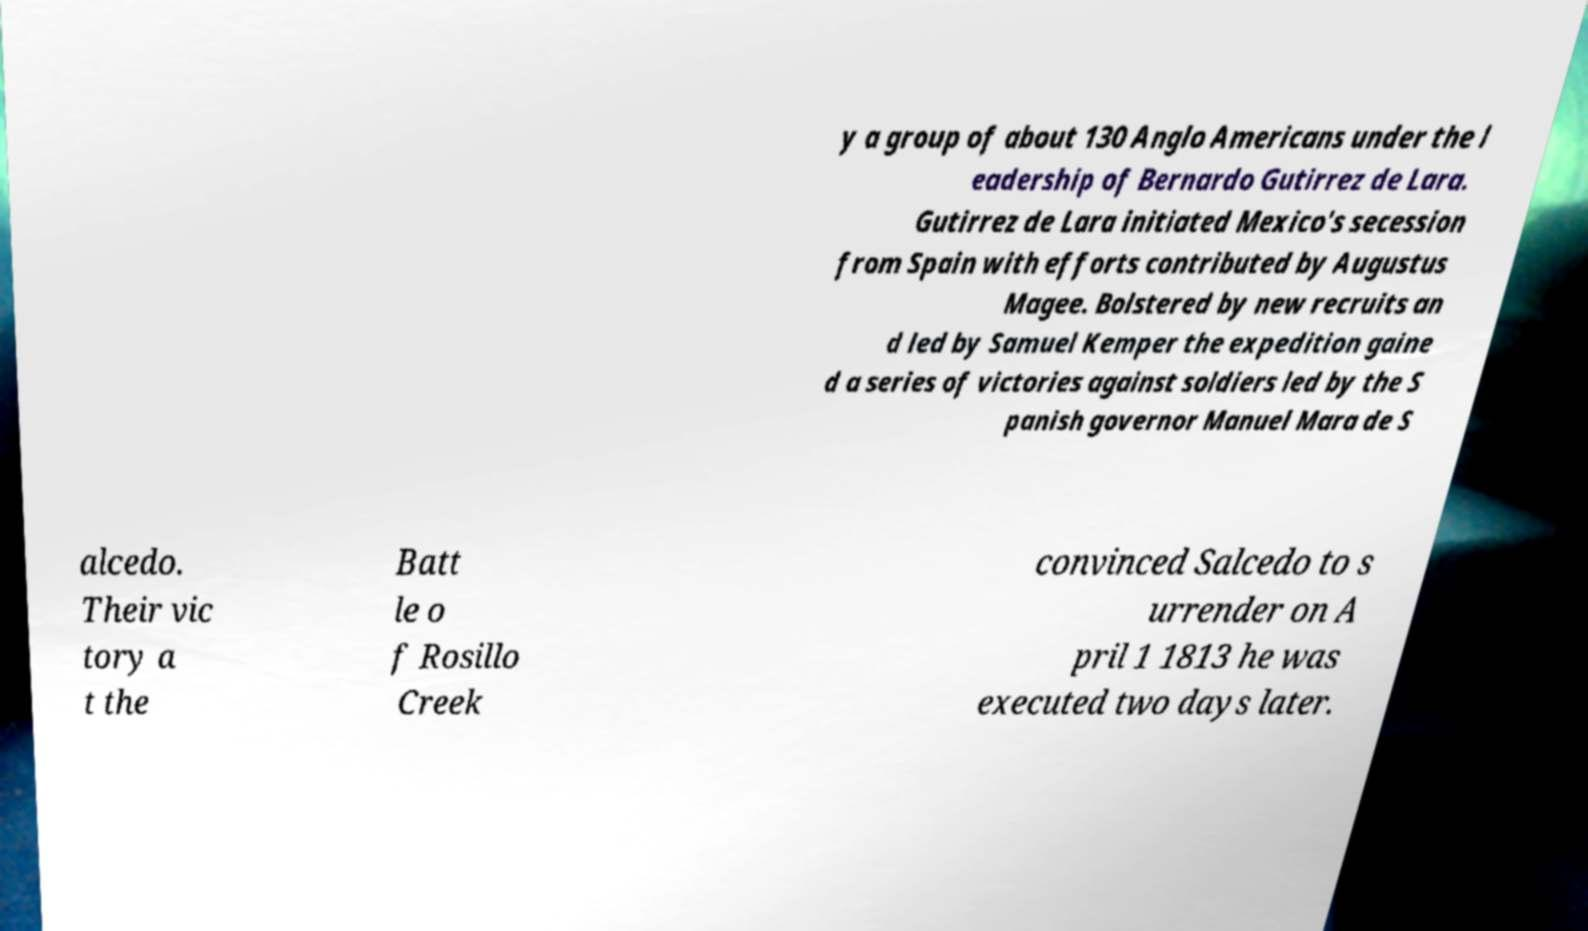Please read and relay the text visible in this image. What does it say? y a group of about 130 Anglo Americans under the l eadership of Bernardo Gutirrez de Lara. Gutirrez de Lara initiated Mexico's secession from Spain with efforts contributed by Augustus Magee. Bolstered by new recruits an d led by Samuel Kemper the expedition gaine d a series of victories against soldiers led by the S panish governor Manuel Mara de S alcedo. Their vic tory a t the Batt le o f Rosillo Creek convinced Salcedo to s urrender on A pril 1 1813 he was executed two days later. 